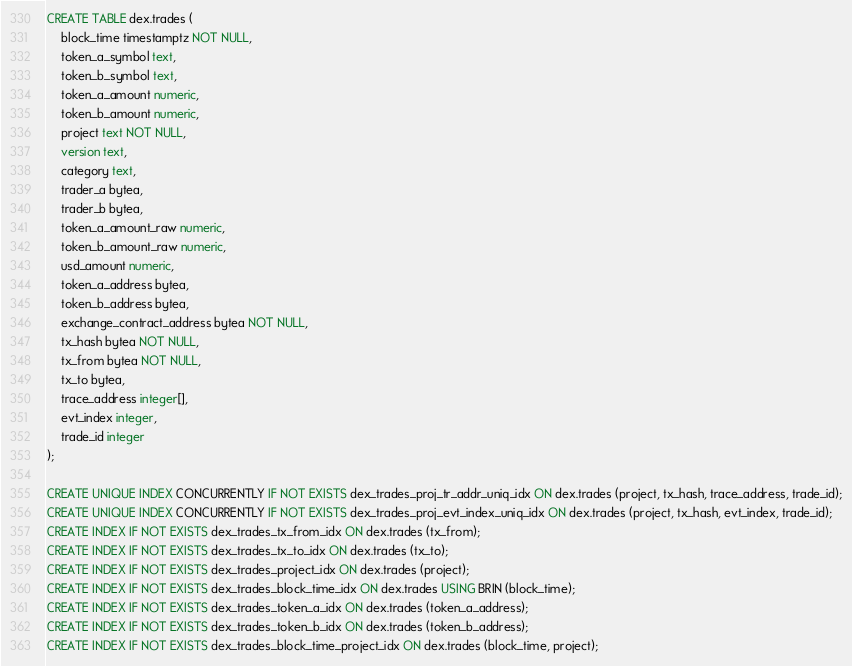<code> <loc_0><loc_0><loc_500><loc_500><_SQL_>CREATE TABLE dex.trades (
    block_time timestamptz NOT NULL,
    token_a_symbol text,
    token_b_symbol text,
    token_a_amount numeric,
    token_b_amount numeric,
    project text NOT NULL,
    version text,
    category text,
    trader_a bytea,
    trader_b bytea,
    token_a_amount_raw numeric,
    token_b_amount_raw numeric,
    usd_amount numeric,
    token_a_address bytea,
    token_b_address bytea,
    exchange_contract_address bytea NOT NULL,
    tx_hash bytea NOT NULL,
    tx_from bytea NOT NULL,
    tx_to bytea,
    trace_address integer[],
    evt_index integer,
    trade_id integer
);

CREATE UNIQUE INDEX CONCURRENTLY IF NOT EXISTS dex_trades_proj_tr_addr_uniq_idx ON dex.trades (project, tx_hash, trace_address, trade_id);
CREATE UNIQUE INDEX CONCURRENTLY IF NOT EXISTS dex_trades_proj_evt_index_uniq_idx ON dex.trades (project, tx_hash, evt_index, trade_id);
CREATE INDEX IF NOT EXISTS dex_trades_tx_from_idx ON dex.trades (tx_from);
CREATE INDEX IF NOT EXISTS dex_trades_tx_to_idx ON dex.trades (tx_to);
CREATE INDEX IF NOT EXISTS dex_trades_project_idx ON dex.trades (project);
CREATE INDEX IF NOT EXISTS dex_trades_block_time_idx ON dex.trades USING BRIN (block_time);
CREATE INDEX IF NOT EXISTS dex_trades_token_a_idx ON dex.trades (token_a_address);
CREATE INDEX IF NOT EXISTS dex_trades_token_b_idx ON dex.trades (token_b_address);
CREATE INDEX IF NOT EXISTS dex_trades_block_time_project_idx ON dex.trades (block_time, project);
</code> 